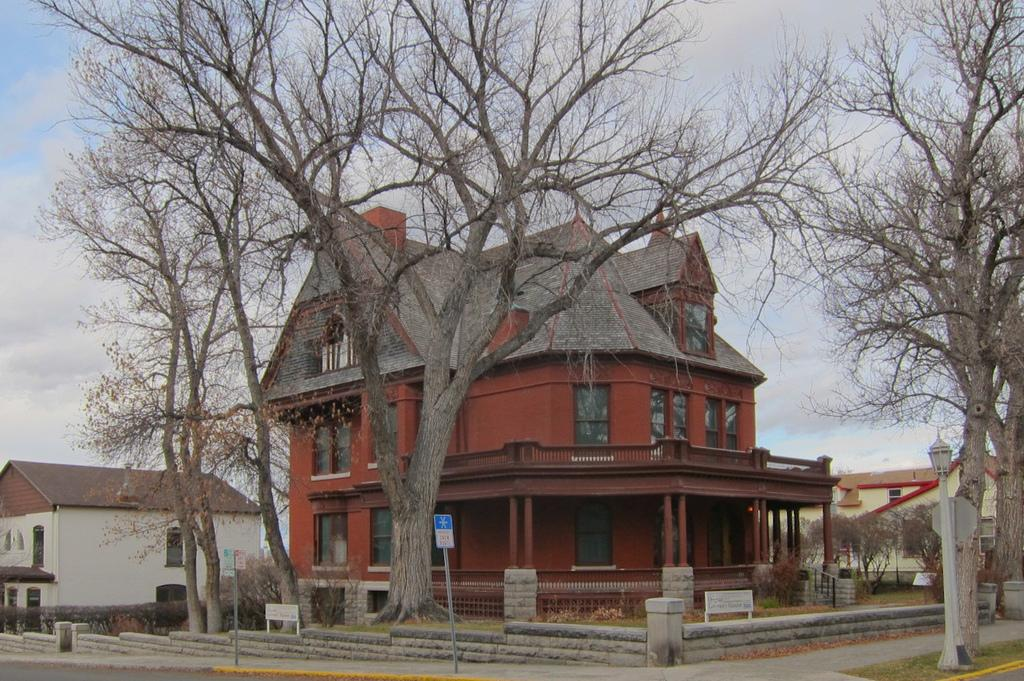What type of structure is visible in the image? There is a building in the image. Are there any residential structures in the image? Yes, there are houses in the image. What type of natural elements can be seen in the image? There are trees in the image. What might be used for identification purposes in the image? There are name boards in the image. What else can be seen in the image besides the mentioned elements? There are other objects in the image. What is visible in the background of the image? The sky is visible in the background of the image. Can you describe the action of the jellyfish in the image? There are no jellyfish present in the image. How many eyes can be seen on the trees in the image? Trees do not have eyes, so this question cannot be answered. 